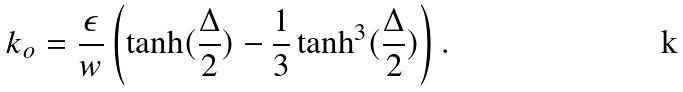<formula> <loc_0><loc_0><loc_500><loc_500>k _ { o } = \frac { \epsilon } { w } \left ( \tanh ( \frac { \Delta } { 2 } ) - \frac { 1 } { 3 } \tanh ^ { 3 } ( \frac { \Delta } { 2 } ) \right ) .</formula> 